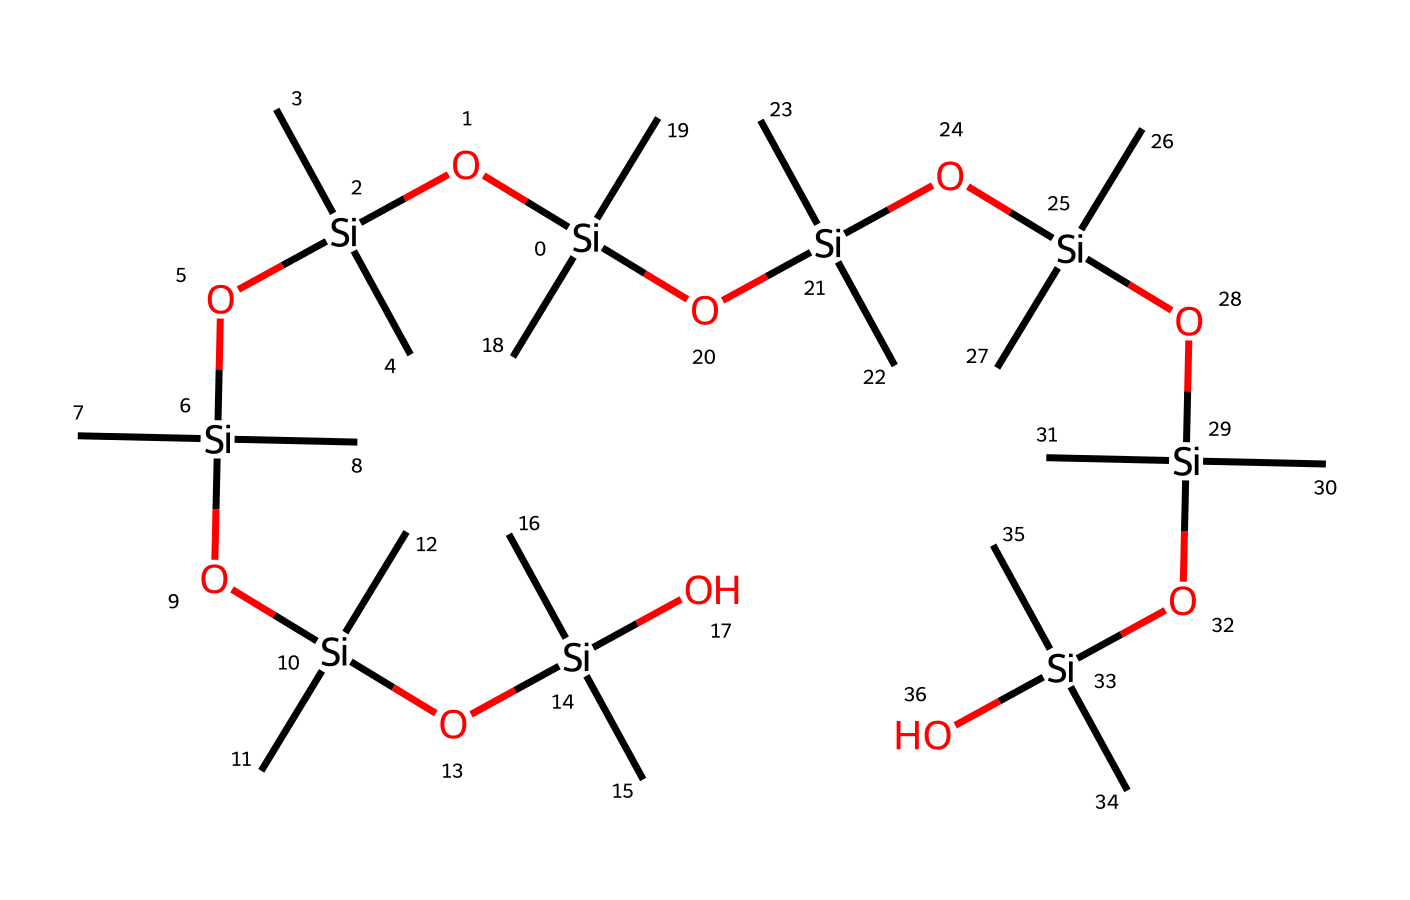What is the primary element in this chemical structure? By examining the SMILES representation, we can see the presence of silicon denoted by the symbol 'Si'. This element is central to the structure of organosilicon compounds and is repeated throughout the chemical.
Answer: silicon How many silicon atoms are in this chemical? From the SMILES representation, we can count the number of 'Si' occurrences. In this case, there are 8 silicon atoms in total, each denoting a central element in the structure of the silicone-based adhesive.
Answer: 8 What type of bonding is predominantly present in this chemical? The SMILES representation indicates multiple silicon-oxygen linkages (Si-O), which are characteristic of organosilicon compounds. These connections highlight the network-like structure typical of siloxanes, showing silicon atoms bonded to oxygen.
Answer: siloxane How many terminal hydroxyl groups are present? Analyzing the structure, there are terminal -OH groups (-O[Si](C)(C)) at the ends of the chains, indicating these groups are present as terminal functional groups. Upon examination, there are 4 hydroxyl groups in total in this adhesive.
Answer: 4 What does the repeating unit in the structure suggest about its properties? The repeating units of silicon and oxygen suggest that the chemical has a flexible and resilient nature, which is beneficial for adhesives used in footwear. This structure indicates that the adhesive can maintain elasticity and bond strength under varying conditions.
Answer: elasticity and resilience What types of side groups are present in this chemical structure? The presence of (C)(C) indicates there are methyl side groups attached to the silicon atoms. This characteristic suggests the additive properties that can enhance the thermal stability and hydrophobic nature of the silicone-based adhesive.
Answer: methyl groups 